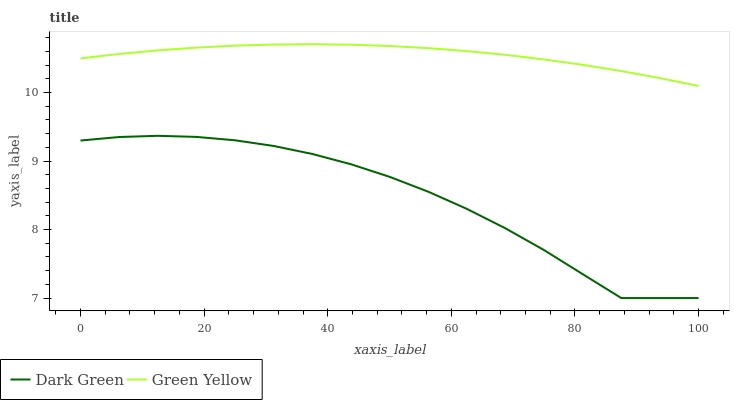Does Dark Green have the maximum area under the curve?
Answer yes or no. No. Is Dark Green the smoothest?
Answer yes or no. No. Does Dark Green have the highest value?
Answer yes or no. No. Is Dark Green less than Green Yellow?
Answer yes or no. Yes. Is Green Yellow greater than Dark Green?
Answer yes or no. Yes. Does Dark Green intersect Green Yellow?
Answer yes or no. No. 